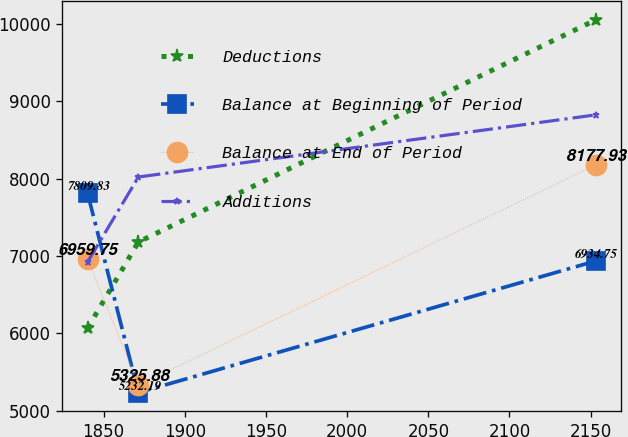<chart> <loc_0><loc_0><loc_500><loc_500><line_chart><ecel><fcel>Deductions<fcel>Balance at Beginning of Period<fcel>Balance at End of Period<fcel>Additions<nl><fcel>1840.1<fcel>6067.15<fcel>7809.83<fcel>6959.75<fcel>6923.55<nl><fcel>1871.4<fcel>7180.85<fcel>5232.19<fcel>5325.88<fcel>8021.87<nl><fcel>2153.06<fcel>10053.7<fcel>6934.75<fcel>8177.93<fcel>8825.55<nl></chart> 